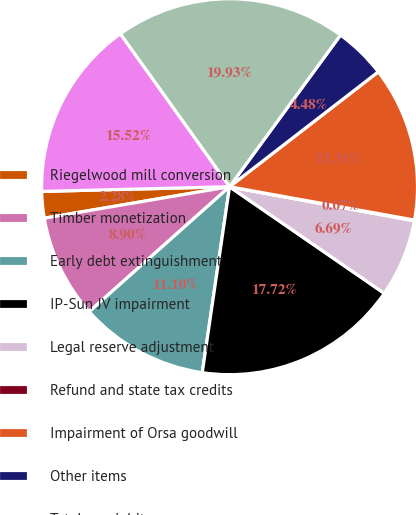Convert chart. <chart><loc_0><loc_0><loc_500><loc_500><pie_chart><fcel>Riegelwood mill conversion<fcel>Timber monetization<fcel>Early debt extinguishment<fcel>IP-Sun JV impairment<fcel>Legal reserve adjustment<fcel>Refund and state tax credits<fcel>Impairment of Orsa goodwill<fcel>Other items<fcel>Total special items<fcel>Non-operating pension expense<nl><fcel>2.28%<fcel>8.9%<fcel>11.1%<fcel>17.72%<fcel>6.69%<fcel>0.07%<fcel>13.31%<fcel>4.48%<fcel>19.93%<fcel>15.52%<nl></chart> 